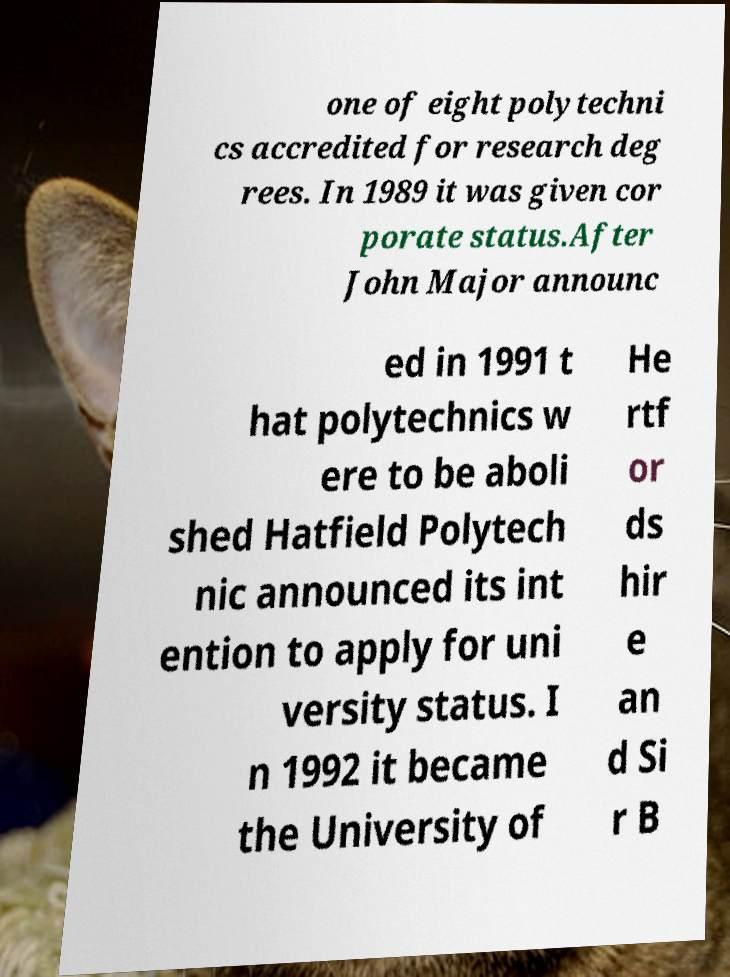Can you read and provide the text displayed in the image?This photo seems to have some interesting text. Can you extract and type it out for me? one of eight polytechni cs accredited for research deg rees. In 1989 it was given cor porate status.After John Major announc ed in 1991 t hat polytechnics w ere to be aboli shed Hatfield Polytech nic announced its int ention to apply for uni versity status. I n 1992 it became the University of He rtf or ds hir e an d Si r B 